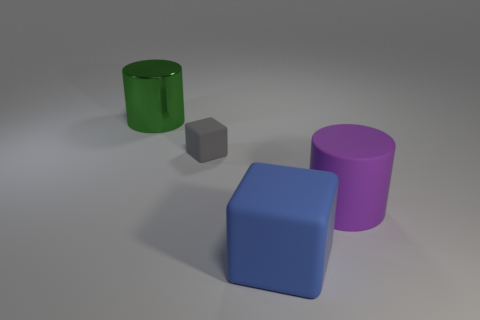Is there anything else that has the same size as the gray object?
Your answer should be compact. No. What is the size of the blue rubber block?
Provide a succinct answer. Large. Do the large rubber cylinder and the small rubber thing have the same color?
Keep it short and to the point. No. What number of things are either yellow rubber blocks or objects right of the green metallic cylinder?
Make the answer very short. 3. How many matte things are to the left of the thing in front of the cylinder that is in front of the green metal cylinder?
Your answer should be compact. 1. How many purple rubber things are there?
Give a very brief answer. 1. Do the matte object that is left of the blue matte cube and the green shiny cylinder have the same size?
Offer a very short reply. No. How many metal objects are purple objects or big blocks?
Give a very brief answer. 0. There is a block that is behind the large blue thing; how many rubber cylinders are to the left of it?
Offer a very short reply. 0. What is the shape of the large thing that is to the left of the large rubber cylinder and right of the small gray rubber thing?
Offer a very short reply. Cube. 